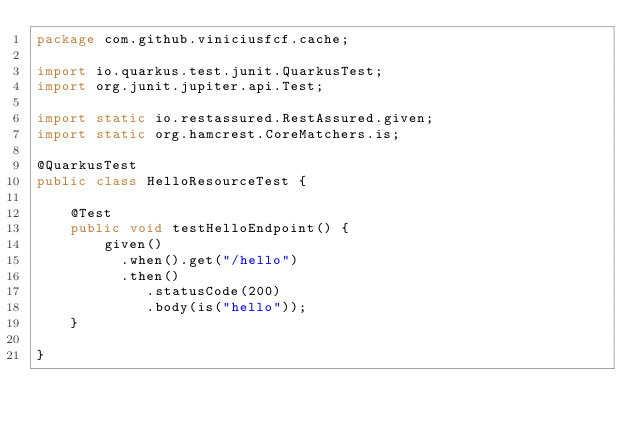Convert code to text. <code><loc_0><loc_0><loc_500><loc_500><_Java_>package com.github.viniciusfcf.cache;

import io.quarkus.test.junit.QuarkusTest;
import org.junit.jupiter.api.Test;

import static io.restassured.RestAssured.given;
import static org.hamcrest.CoreMatchers.is;

@QuarkusTest
public class HelloResourceTest {

    @Test
    public void testHelloEndpoint() {
        given()
          .when().get("/hello")
          .then()
             .statusCode(200)
             .body(is("hello"));
    }

}</code> 